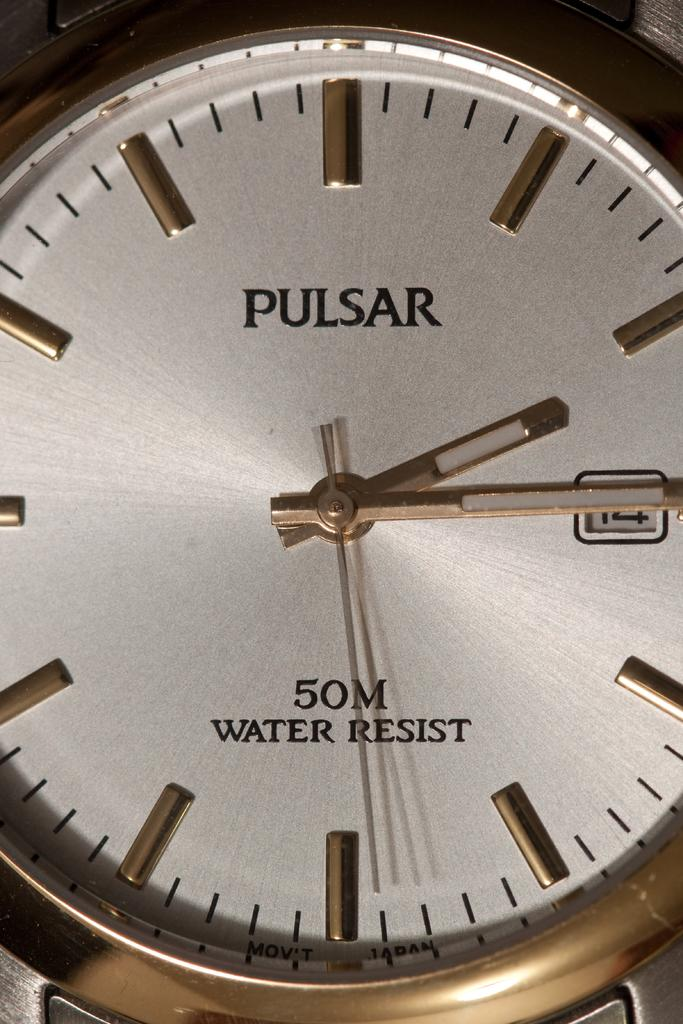<image>
Describe the image concisely. The Pulsar watch is water resistant up to 50 meters. 